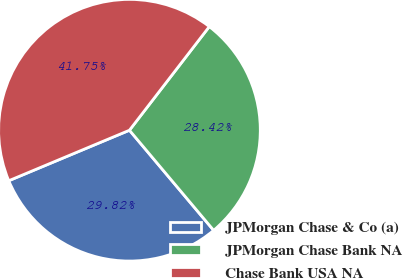<chart> <loc_0><loc_0><loc_500><loc_500><pie_chart><fcel>JPMorgan Chase & Co (a)<fcel>JPMorgan Chase Bank NA<fcel>Chase Bank USA NA<nl><fcel>29.82%<fcel>28.42%<fcel>41.75%<nl></chart> 